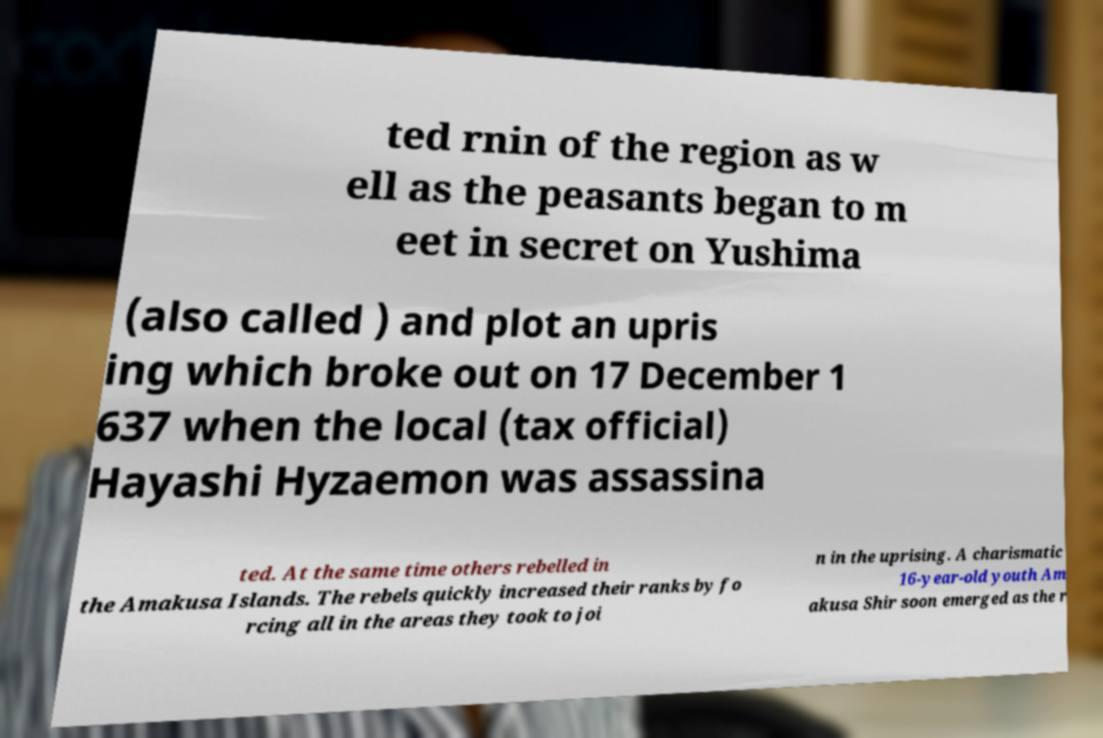Could you assist in decoding the text presented in this image and type it out clearly? ted rnin of the region as w ell as the peasants began to m eet in secret on Yushima (also called ) and plot an upris ing which broke out on 17 December 1 637 when the local (tax official) Hayashi Hyzaemon was assassina ted. At the same time others rebelled in the Amakusa Islands. The rebels quickly increased their ranks by fo rcing all in the areas they took to joi n in the uprising. A charismatic 16-year-old youth Am akusa Shir soon emerged as the r 